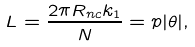<formula> <loc_0><loc_0><loc_500><loc_500>L = \frac { 2 \pi R _ { n c } k _ { 1 } } { N } = p | \theta | ,</formula> 